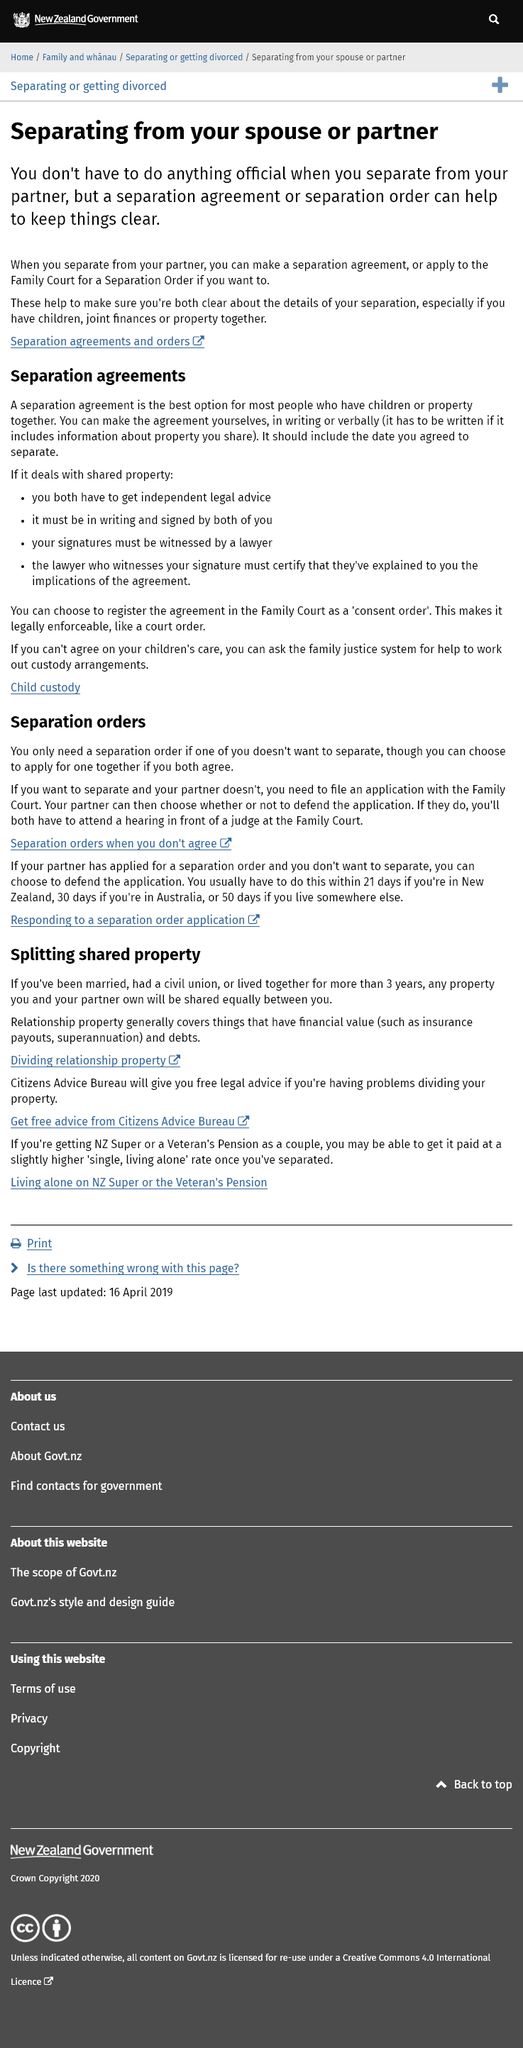Highlight a few significant elements in this photo. You can make a separation from your partner or spouse official by either entering into a separation agreement or obtaining a Separation Order. The Family Court is the appropriate institution where a Separatyion Order application should be filed. It is not necessary for you to take any official action to end your relationship with your partner. 